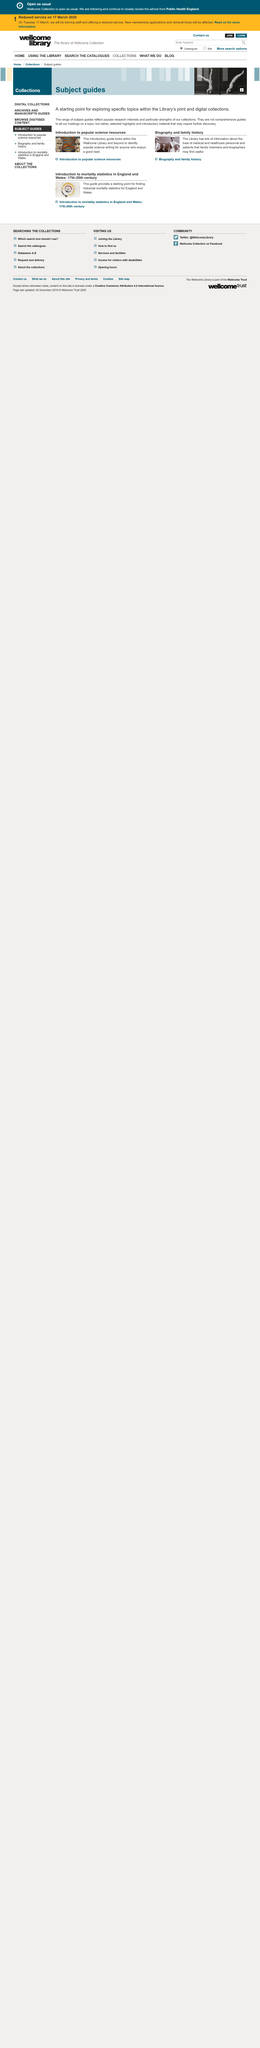Give some essential details in this illustration. The introduction to popular science resources examines the Wellcome Library and other sources to identify popular science writing. The Library's Subject guides are comprehensive resources that provide an overview of specific topics within the Library's collections. The Library has a significant amount of information about the lives of medical and healthcare personnel. 